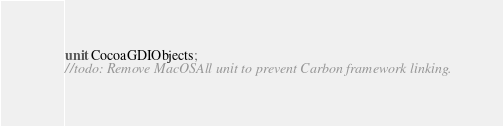<code> <loc_0><loc_0><loc_500><loc_500><_Pascal_>unit CocoaGDIObjects;
//todo: Remove MacOSAll unit to prevent Carbon framework linking.</code> 